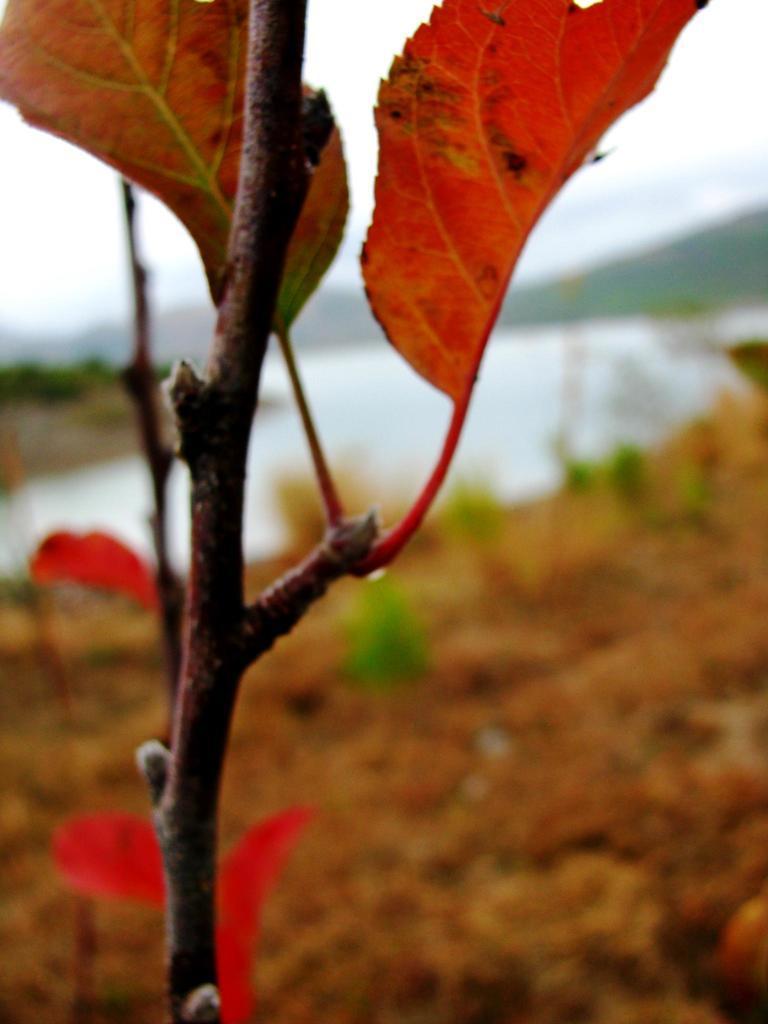How would you summarize this image in a sentence or two? In this image, we can see a stem of a plant, there are two leaves and there is a blur background, we can see sand and water. 